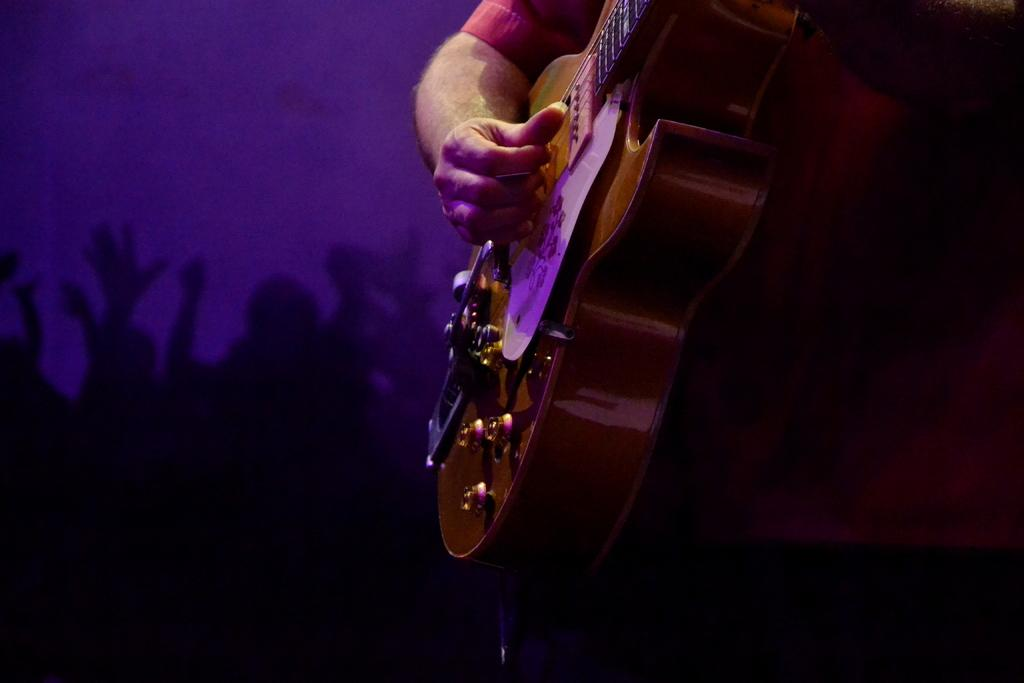What is the main subject of the image? There is a man in the image. What is the man holding in the image? The man is holding a guitar. What type of throne is the man sitting on in the image? There is no throne present in the image; the man is standing and holding a guitar. How many wheels can be seen on the guitar in the image? There are no wheels on the guitar in the image; it is a standard guitar without any additional features. 